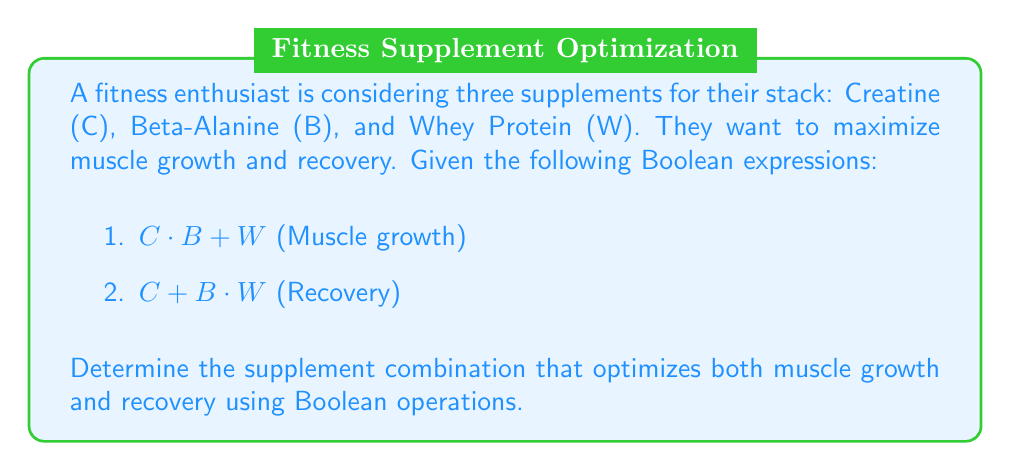What is the answer to this math problem? Let's approach this step-by-step using Boolean algebra:

1) First, we need to find the combination that satisfies both expressions. We can do this by ANDing the two expressions:

   $(C \cdot B + W) \cdot (C + B \cdot W)$

2) Expand this expression using the distributive law:

   $(C \cdot B \cdot C) + (C \cdot B \cdot B \cdot W) + (W \cdot C) + (W \cdot B \cdot W)$

3) Simplify using Boolean algebra rules:
   - $C \cdot C = C$
   - $B \cdot B = B$
   - $W \cdot W = W$

   $(C \cdot B) + (C \cdot B \cdot W) + (W \cdot C) + (W \cdot B)$

4) Further simplify:
   - $(C \cdot B)$ is already in its simplest form
   - $(W \cdot C)$ is already in its simplest form
   - $(W \cdot B)$ is already in its simplest form
   - $(C \cdot B \cdot W)$ is a subset of $(C \cdot B)$, so it can be removed

   $(C \cdot B) + (W \cdot C) + (W \cdot B)$

5) This final expression represents the optimal combinations:
   - Creatine AND Beta-Alanine
   - Whey Protein AND Creatine
   - Whey Protein AND Beta-Alanine

6) The combination that satisfies all of these is taking all three supplements: Creatine, Beta-Alanine, and Whey Protein.
Answer: $C \cdot B \cdot W$ 